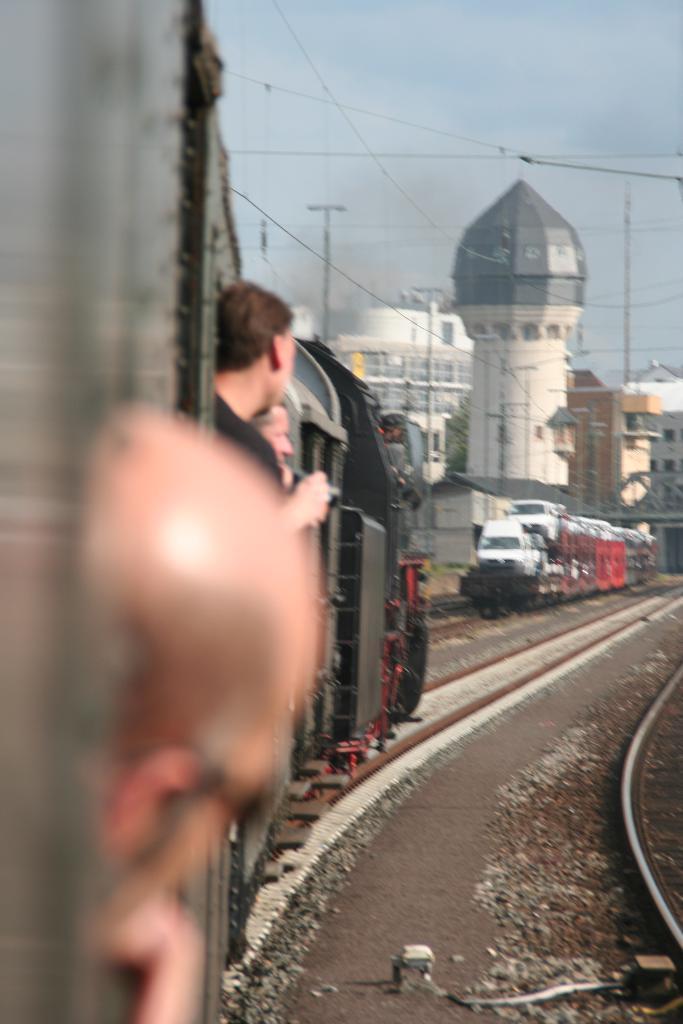How would you summarize this image in a sentence or two? On the left side, there are three persons in a train which is on a railway track. On the right side, there is another railway track. In the background, there is a another train on another railway track, there are poles, buildings and there are clouds in the sky. 